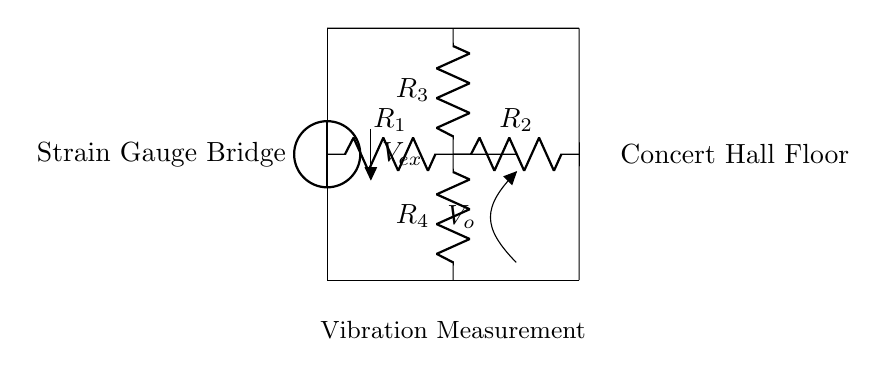What type of circuit is represented? The circuit is a strain gauge bridge, identified by the arrangement of resistors and the presence of a voltage measurement across one section of the circuit.
Answer: Strain gauge bridge What is the purpose of the voltage source? The voltage source provides the excitation voltage, which is necessary to operate the strain gauge bridge and produce a measurable output voltage based on strain.
Answer: Excitation voltage How many resistors are in this circuit? There are four resistors connected in a configuration that allows them to form a bridge, and this configuration is essential for measuring differential voltage caused by vibration.
Answer: Four What does the output voltage represent? The output voltage indicates the difference in resistance caused by the strain gauges reacting to vibrations in the concert hall floor, allowing for measurement of those vibrations.
Answer: Vibration measurement What is the role of the strain gauge in this circuit? The strain gauge measures the deformation or strain on the concert hall floor due to vibrations, changing its resistance, which contributes to the output voltage of the bridge.
Answer: Measure strain Which resistors are part of the upper and lower arms of the bridge? The upper arm consists of resistors R1 and R2, while the lower arm consists of resistors R3 and R4, crucial for comparing resistance changes due to strain.
Answer: R1, R2 (upper); R3, R4 (lower) 